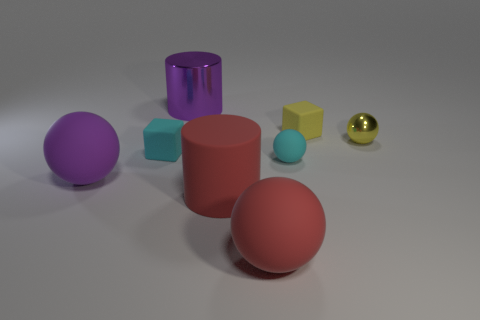Add 2 shiny things. How many objects exist? 10 Subtract all cylinders. How many objects are left? 6 Subtract 0 green cubes. How many objects are left? 8 Subtract all purple rubber cubes. Subtract all yellow cubes. How many objects are left? 7 Add 4 small yellow things. How many small yellow things are left? 6 Add 5 large red metallic cylinders. How many large red metallic cylinders exist? 5 